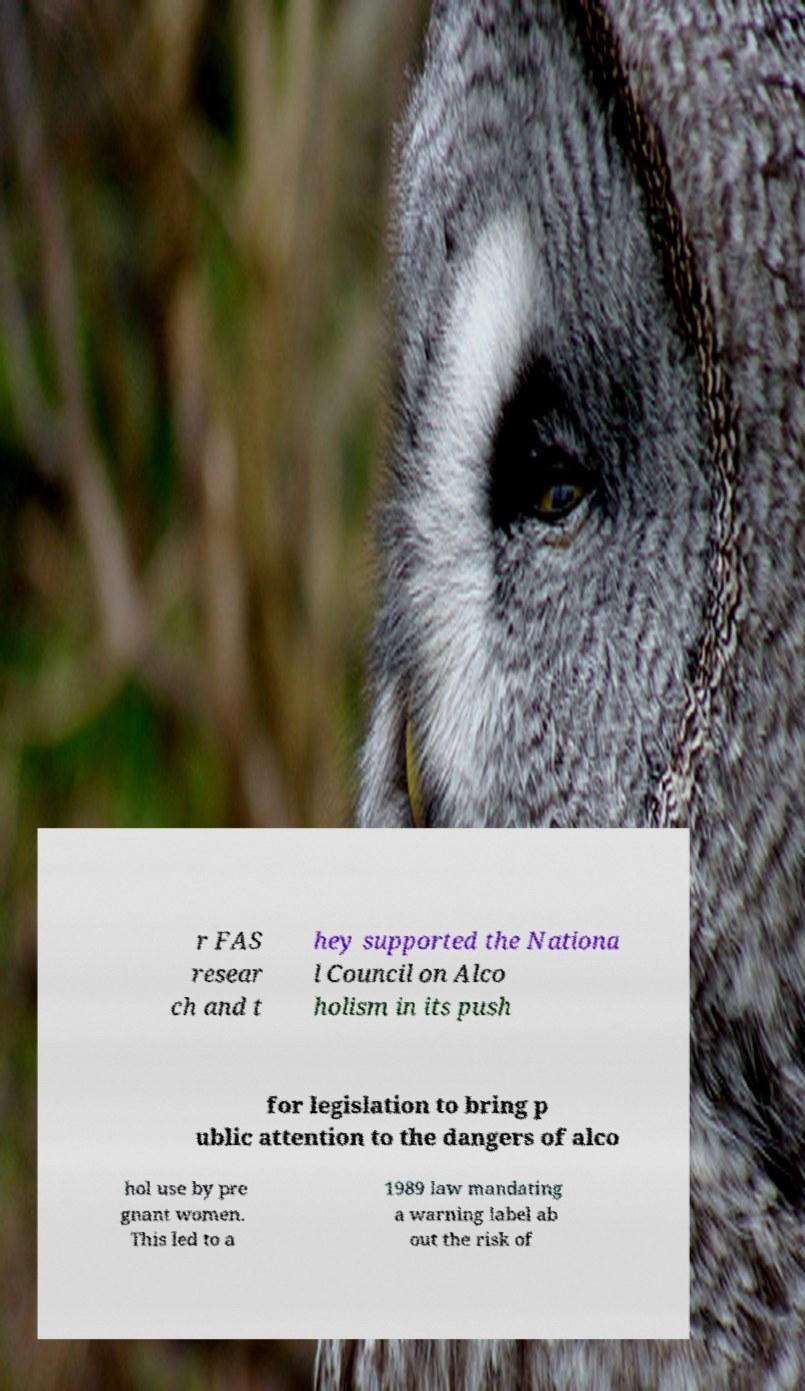For documentation purposes, I need the text within this image transcribed. Could you provide that? r FAS resear ch and t hey supported the Nationa l Council on Alco holism in its push for legislation to bring p ublic attention to the dangers of alco hol use by pre gnant women. This led to a 1989 law mandating a warning label ab out the risk of 